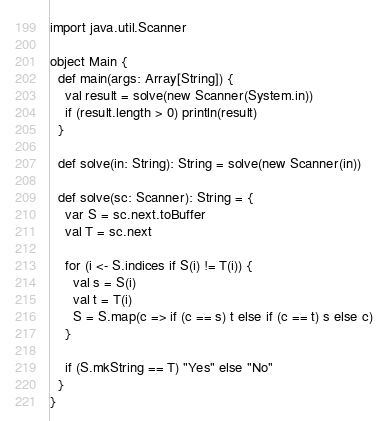Convert code to text. <code><loc_0><loc_0><loc_500><loc_500><_Scala_>import java.util.Scanner

object Main {
  def main(args: Array[String]) {
    val result = solve(new Scanner(System.in))
    if (result.length > 0) println(result)
  }

  def solve(in: String): String = solve(new Scanner(in))

  def solve(sc: Scanner): String = {
    var S = sc.next.toBuffer
    val T = sc.next

    for (i <- S.indices if S(i) != T(i)) {
      val s = S(i)
      val t = T(i)
      S = S.map(c => if (c == s) t else if (c == t) s else c)
    }

    if (S.mkString == T) "Yes" else "No"
  }
}
</code> 